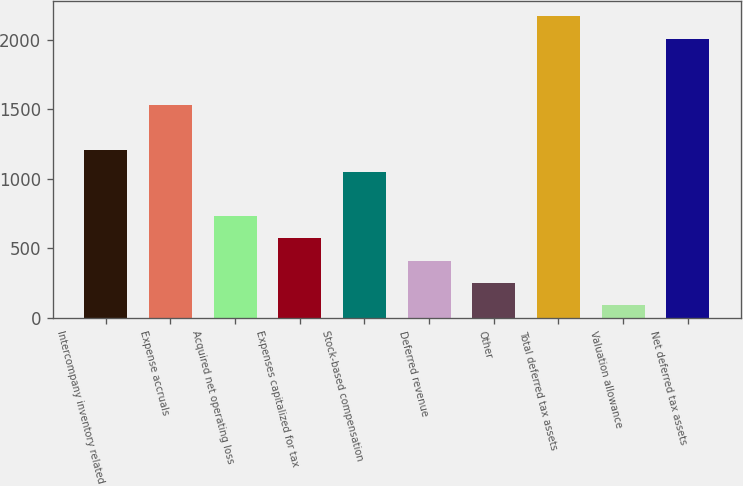Convert chart. <chart><loc_0><loc_0><loc_500><loc_500><bar_chart><fcel>Intercompany inventory related<fcel>Expense accruals<fcel>Acquired net operating loss<fcel>Expenses capitalized for tax<fcel>Stock-based compensation<fcel>Deferred revenue<fcel>Other<fcel>Total deferred tax assets<fcel>Valuation allowance<fcel>Net deferred tax assets<nl><fcel>1210.6<fcel>1530.2<fcel>731.2<fcel>571.4<fcel>1050.8<fcel>411.6<fcel>251.8<fcel>2169.4<fcel>92<fcel>2009.6<nl></chart> 